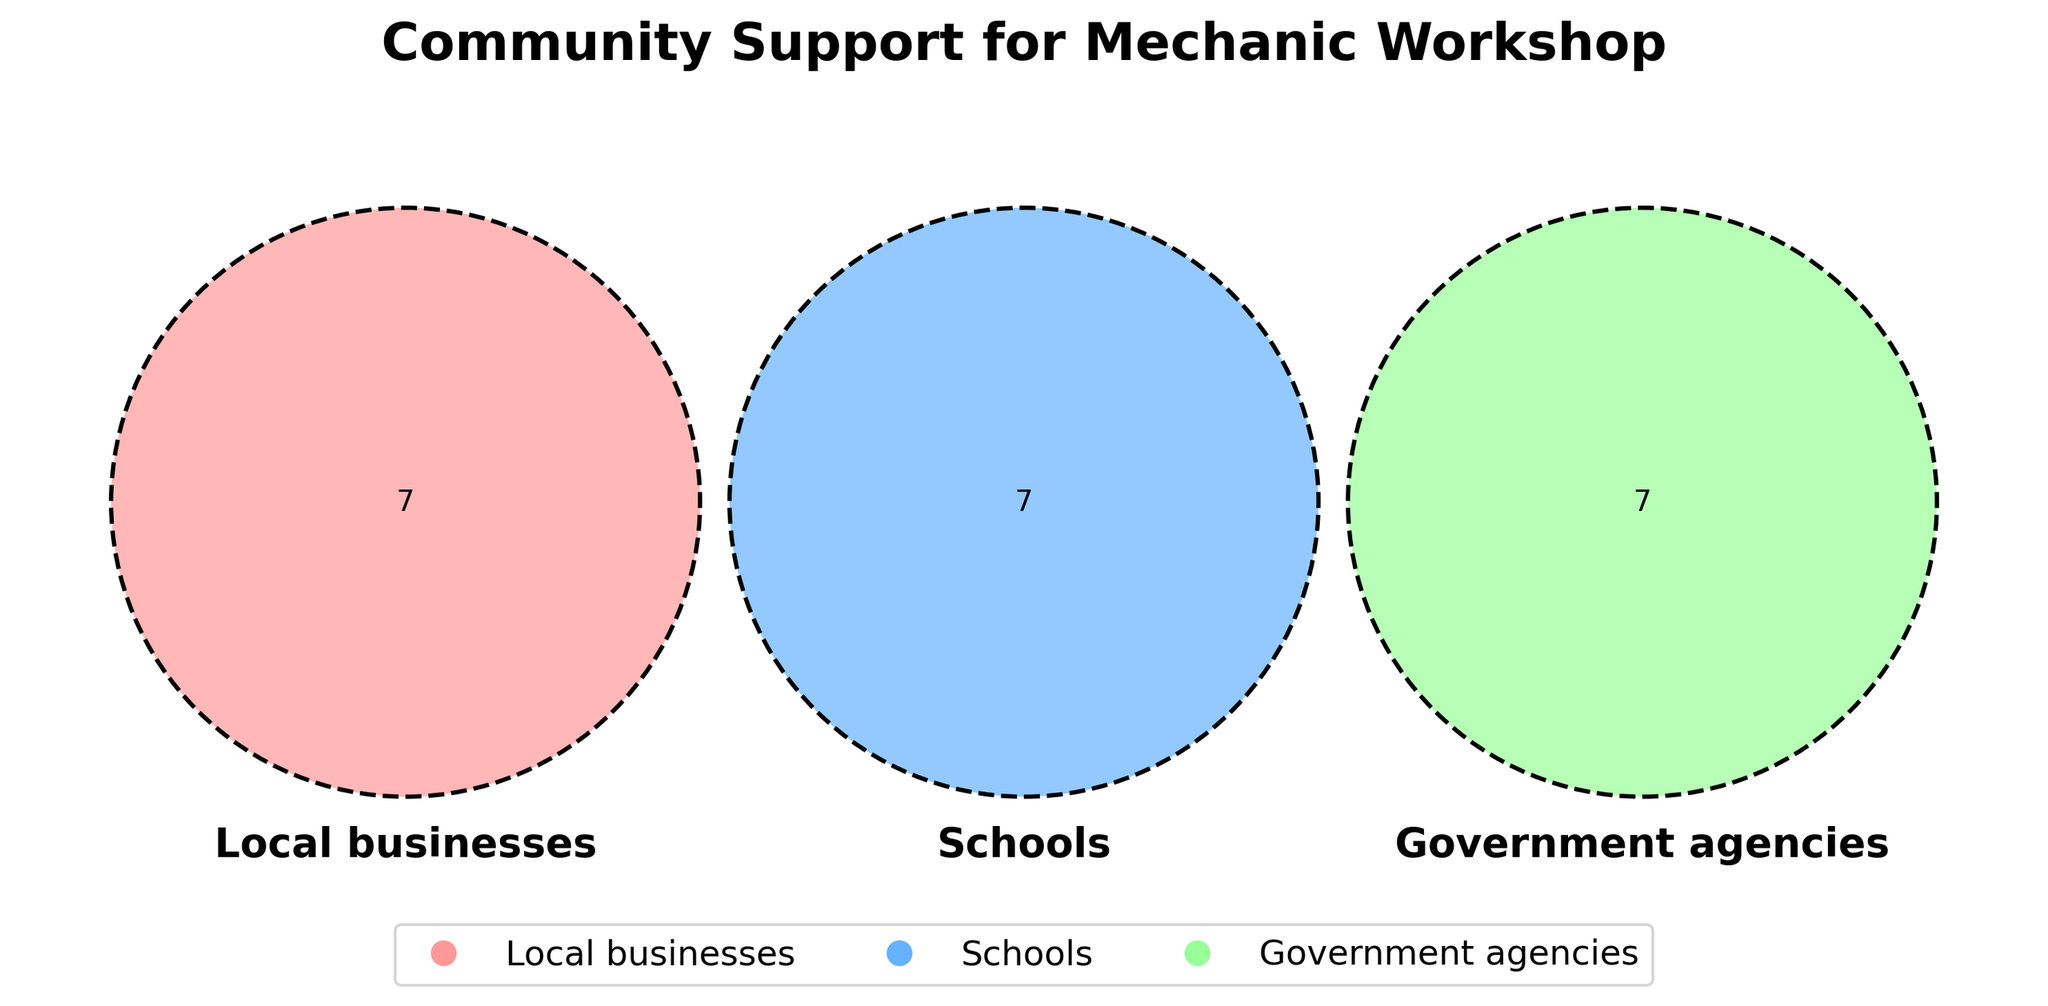Which organization types support the Community Support for Mechanic Workshop? The title and labels of the Venn diagram indicate that the three circles represent Local businesses, Schools, and Government agencies.
Answer: Local businesses, Schools, Government agencies What color represents Schools in the Venn diagram? Each circle in the Venn diagram has a different color. The circle labeled "Schools" is filled with a light blue color.
Answer: Light Blue How many organizations support both Local businesses and Schools but not Government agencies? Check the overlapping area between the circles for Local businesses and Schools that does not intersect with the Government agencies circle.
Answer: 0 Is there any organization that supports Local businesses, Schools, and Government agencies? Look at the central overlapping area where all three circles intersect to see if there is any organization listed.
Answer: No Which circle represents Government agencies in the Venn diagram? Each circle in the Venn diagram is labeled. Find the circle labeled "Government agencies" which is filled with green color.
Answer: Green How many Local businesses are part of the Community Support for Mechanic Workshop? Count the number of unique names within the Local businesses circle only.
Answer: 7 Do Technical Community College and City Council share any common support with Local businesses? Check if either name appears in the overlap between the circles Local businesses, Schools, and Government agencies.
Answer: No Count the total number of organizations found within all sets mentioned in the Venn diagram. Add all unique organizations listed within each Venn diagram’s circles without counting any organization twice.
Answer: 21 